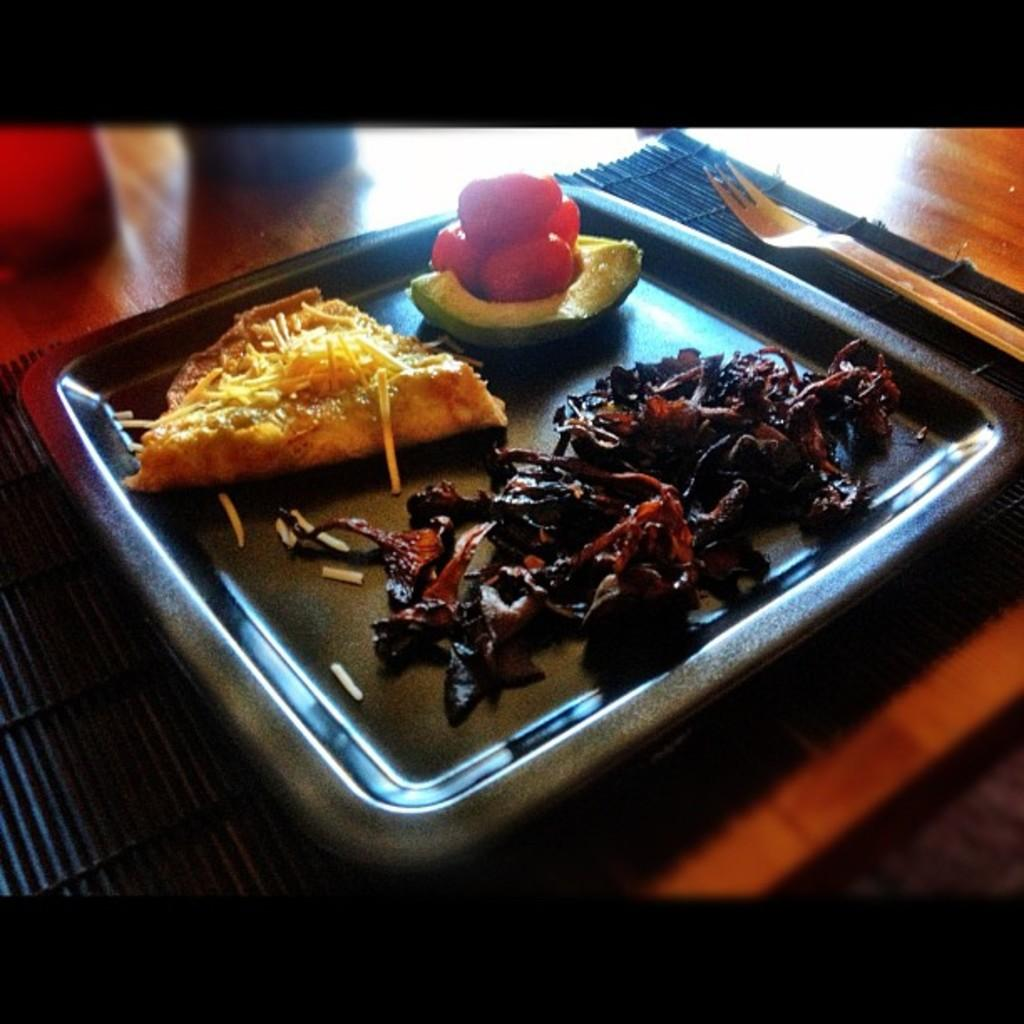What is on the plate that is visible in the image? There is a plate containing food in the image. What is placed under the plate in the image? There is a table mat in the image. What utensil is placed on the table in the image? There is a fork placed on the table in the image. What type of worm can be seen crawling under the table mat in the image? There is no worm present in the image; it only features a plate containing food, a table mat, and a fork. 